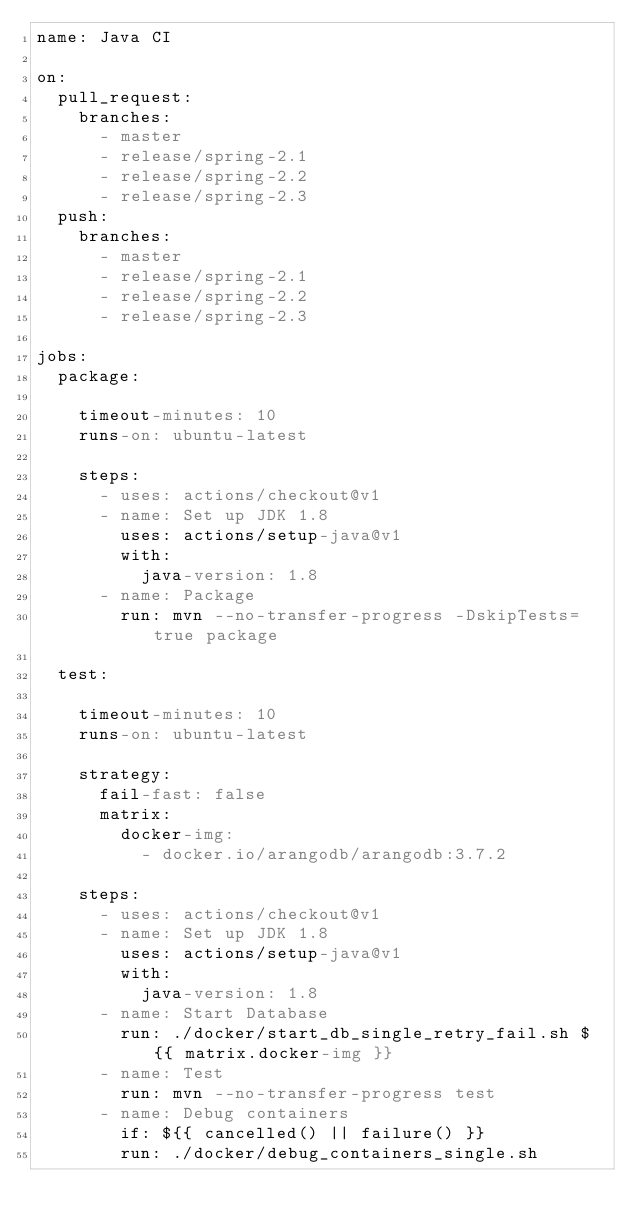Convert code to text. <code><loc_0><loc_0><loc_500><loc_500><_YAML_>name: Java CI

on:
  pull_request:
    branches:
      - master
      - release/spring-2.1
      - release/spring-2.2
      - release/spring-2.3
  push:
    branches:
      - master
      - release/spring-2.1
      - release/spring-2.2
      - release/spring-2.3

jobs:
  package:

    timeout-minutes: 10
    runs-on: ubuntu-latest

    steps:
      - uses: actions/checkout@v1
      - name: Set up JDK 1.8
        uses: actions/setup-java@v1
        with:
          java-version: 1.8
      - name: Package
        run: mvn --no-transfer-progress -DskipTests=true package

  test:

    timeout-minutes: 10
    runs-on: ubuntu-latest

    strategy:
      fail-fast: false
      matrix:
        docker-img:
          - docker.io/arangodb/arangodb:3.7.2

    steps:
      - uses: actions/checkout@v1
      - name: Set up JDK 1.8
        uses: actions/setup-java@v1
        with:
          java-version: 1.8
      - name: Start Database
        run: ./docker/start_db_single_retry_fail.sh ${{ matrix.docker-img }}
      - name: Test
        run: mvn --no-transfer-progress test
      - name: Debug containers
        if: ${{ cancelled() || failure() }}
        run: ./docker/debug_containers_single.sh
</code> 